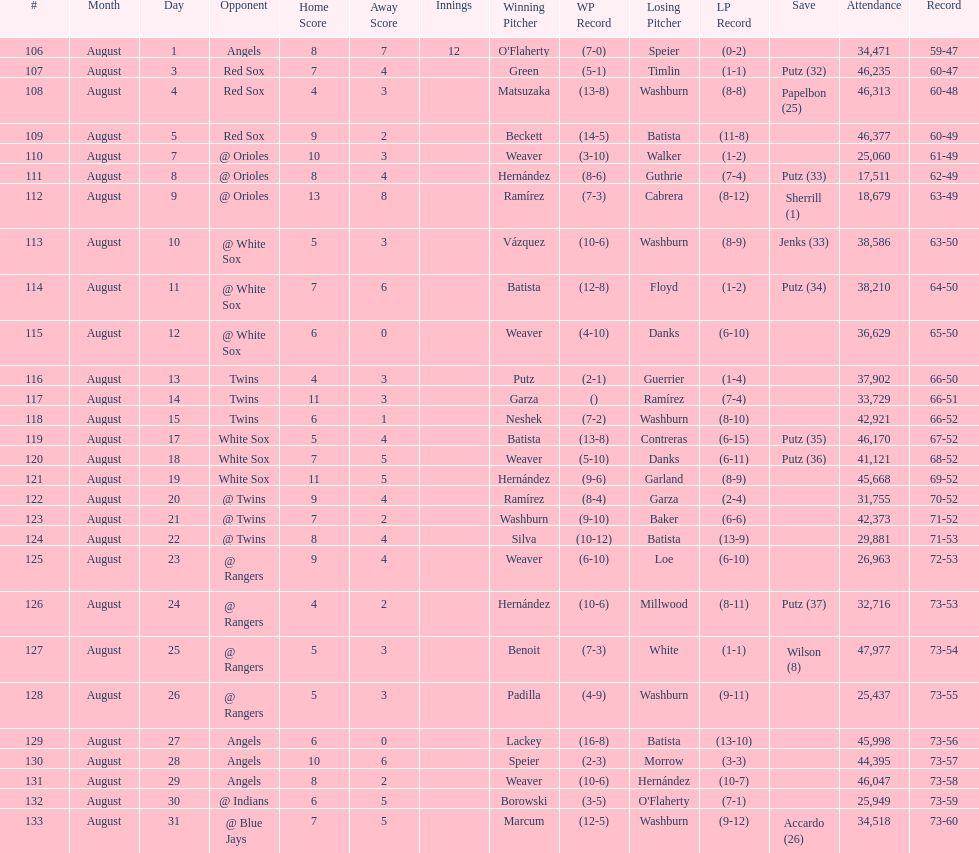What was the total number of games played in august 2007? 28. 